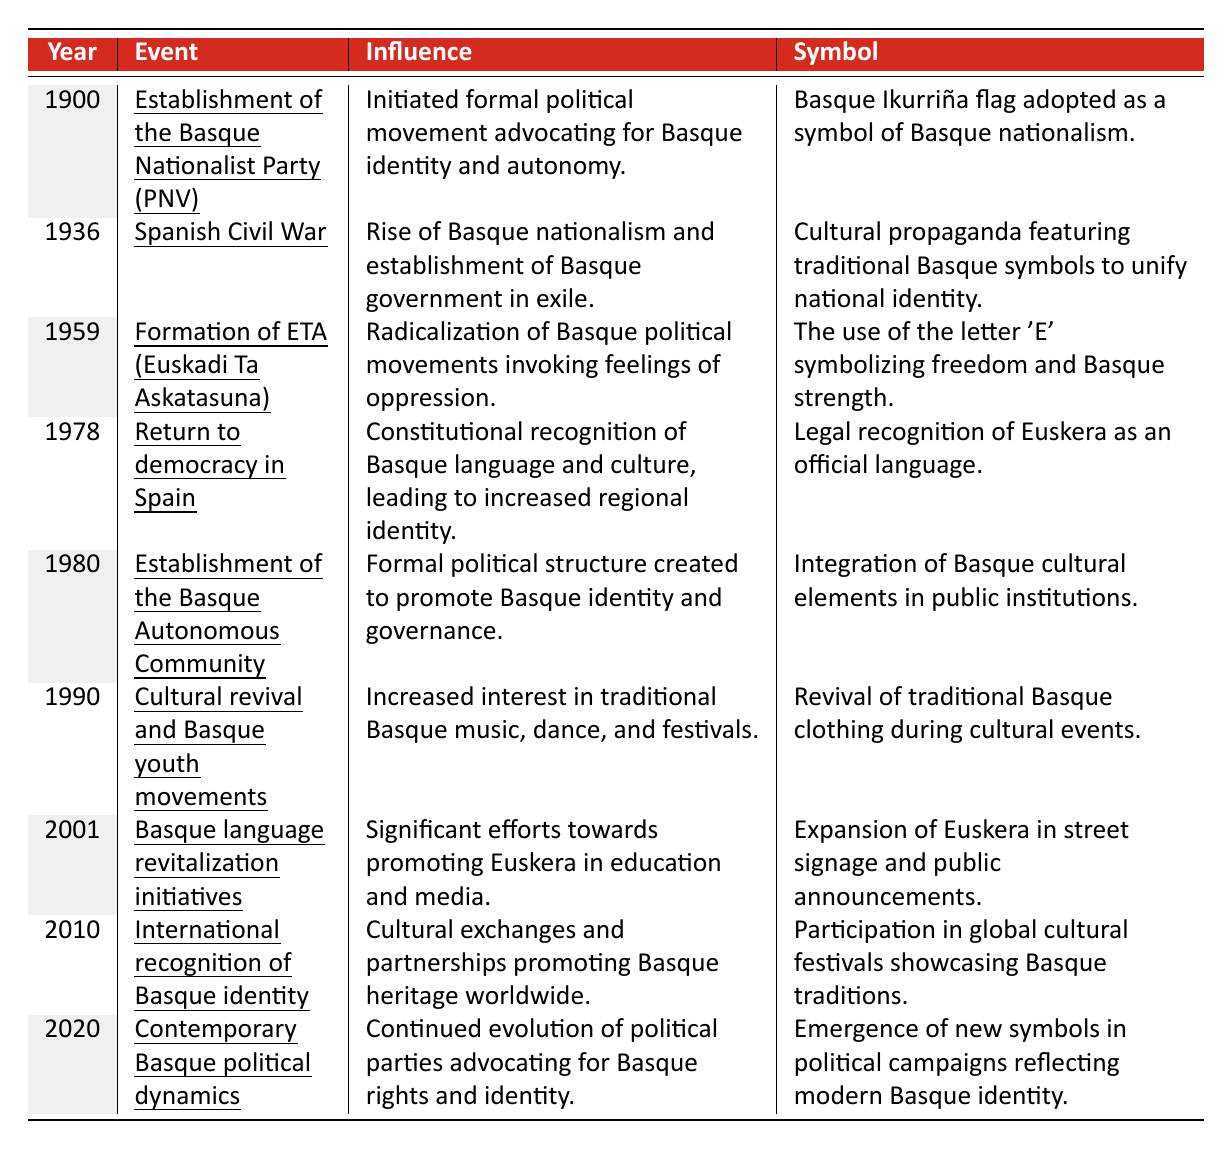What year was the Basque Nationalist Party (PNV) established? The table provides the event "Establishment of the Basque Nationalist Party (PNV)" in the year 1900. Thus, the year of establishment is found directly in the corresponding cell.
Answer: 1900 Which event occurred in 1936 that affected Basque identity? The table shows that the event in 1936 is the "Spanish Civil War," which influenced the rise of Basque nationalism and the establishment of the Basque government in exile.
Answer: Spanish Civil War Did the establishment of the Basque Autonomous Community happen before or after 1990? According to the table, the establishment of the Basque Autonomous Community is listed in 1980, which is before 1990.
Answer: Before What symbol was adopted in 1900 to represent Basque nationalism? The table indicates that the Basque Ikurriña flag was adopted as a symbol of Basque nationalism in 1900. This means the answer refers to the symbol connected with that year.
Answer: Basque Ikurriña flag What is the significance of the year 1978 for the Basque language? The table states that in 1978 there was a constitutional recognition of the Basque language, Euskera, as an official language, thereby increasing regional identity. This indicates its significance in terms of cultural and linguistic recognition.
Answer: Constitutional recognition of Euskera How many years passed between the establishment of ETA and the recognition of Euskera as an official language? ETA was formed in 1959 and Euskera was recognized officially in 1978. To find the number of years passed: 1978 - 1959 = 19 years.
Answer: 19 years What changes regarding the Basque language were initiated in 2001? The table notes that significant revitalization initiatives for the Basque language took place in 2001, which included promoting Euskera in education and media, signifying efforts to enhance its presence.
Answer: Language revitalization initiatives In which years were major cultural movements highlighted, according to the table? The table indicates major cultural movements in the years 1990 (cultural revival and youth movements) and 2010 (international recognition of Basque identity), both of which emphasize the cultural aspects of Basque identity.
Answer: 1990 and 2010 Was the influence of Basque nationalism more prominent during the Spanish Civil War than in the establishment of the Basque Autonomous Community? The influence during the Spanish Civil War (1936) included the rise of nationalism and a government in exile, while the Basque Autonomous Community's establishment (1980) formalized political structure and identity promotion. Since both had significant impacts in different contexts, it's evident that nationalism was notably emphasized during the Civil War.
Answer: Yes How did the events of 2010 relate to previous movements? The table states that in 2010 there was international recognition of Basque identity, building on the cultural exchanges and partnerships developed from earlier events, such as the cultural revival in 1990, indicative of the continuity and growth of Basque identity over the years.
Answer: A continuation of cultural movements 